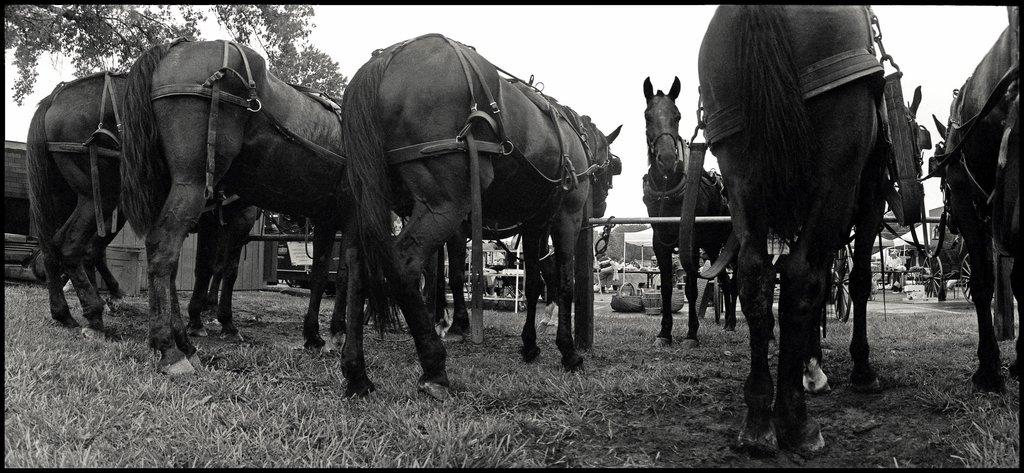What animals are present in the image? There is a herd of horses in the image. How are the horses secured in the image? The horses are tied with rope chains. What type of vegetation can be seen on the left side of the image? There are trees on the left side of the image. What is visible at the top of the image? The sky is visible at the top of the image. Where is the card hidden in the image? There is no card present in the image. Can you see a baby playing with the horses in the image? There is no baby present in the image; it only features a herd of horses tied with rope chains. 